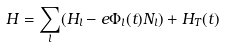<formula> <loc_0><loc_0><loc_500><loc_500>H = \sum _ { l } ( H _ { l } - e \Phi _ { l } ( t ) N _ { l } ) + H _ { T } ( t )</formula> 